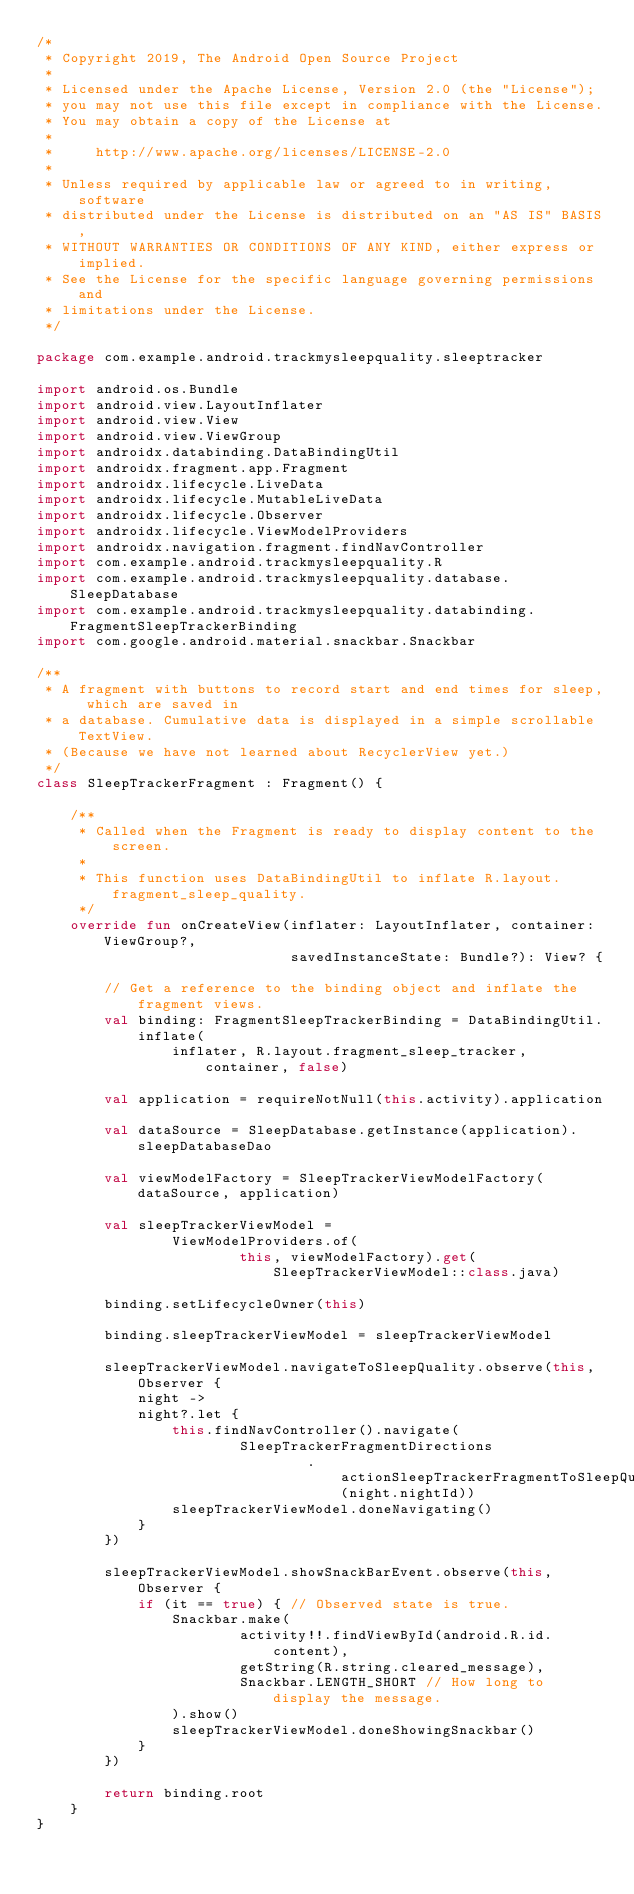Convert code to text. <code><loc_0><loc_0><loc_500><loc_500><_Kotlin_>/*
 * Copyright 2019, The Android Open Source Project
 *
 * Licensed under the Apache License, Version 2.0 (the "License");
 * you may not use this file except in compliance with the License.
 * You may obtain a copy of the License at
 *
 *     http://www.apache.org/licenses/LICENSE-2.0
 *
 * Unless required by applicable law or agreed to in writing, software
 * distributed under the License is distributed on an "AS IS" BASIS,
 * WITHOUT WARRANTIES OR CONDITIONS OF ANY KIND, either express or implied.
 * See the License for the specific language governing permissions and
 * limitations under the License.
 */

package com.example.android.trackmysleepquality.sleeptracker

import android.os.Bundle
import android.view.LayoutInflater
import android.view.View
import android.view.ViewGroup
import androidx.databinding.DataBindingUtil
import androidx.fragment.app.Fragment
import androidx.lifecycle.LiveData
import androidx.lifecycle.MutableLiveData
import androidx.lifecycle.Observer
import androidx.lifecycle.ViewModelProviders
import androidx.navigation.fragment.findNavController
import com.example.android.trackmysleepquality.R
import com.example.android.trackmysleepquality.database.SleepDatabase
import com.example.android.trackmysleepquality.databinding.FragmentSleepTrackerBinding
import com.google.android.material.snackbar.Snackbar

/**
 * A fragment with buttons to record start and end times for sleep, which are saved in
 * a database. Cumulative data is displayed in a simple scrollable TextView.
 * (Because we have not learned about RecyclerView yet.)
 */
class SleepTrackerFragment : Fragment() {

    /**
     * Called when the Fragment is ready to display content to the screen.
     *
     * This function uses DataBindingUtil to inflate R.layout.fragment_sleep_quality.
     */
    override fun onCreateView(inflater: LayoutInflater, container: ViewGroup?,
                              savedInstanceState: Bundle?): View? {

        // Get a reference to the binding object and inflate the fragment views.
        val binding: FragmentSleepTrackerBinding = DataBindingUtil.inflate(
                inflater, R.layout.fragment_sleep_tracker, container, false)

        val application = requireNotNull(this.activity).application

        val dataSource = SleepDatabase.getInstance(application).sleepDatabaseDao

        val viewModelFactory = SleepTrackerViewModelFactory(dataSource, application)

        val sleepTrackerViewModel =
                ViewModelProviders.of(
                        this, viewModelFactory).get(SleepTrackerViewModel::class.java)

        binding.setLifecycleOwner(this)

        binding.sleepTrackerViewModel = sleepTrackerViewModel

        sleepTrackerViewModel.navigateToSleepQuality.observe(this, Observer {
            night ->
            night?.let {
                this.findNavController().navigate(
                        SleepTrackerFragmentDirections
                                .actionSleepTrackerFragmentToSleepQualityFragment(night.nightId))
                sleepTrackerViewModel.doneNavigating()
            }
        })

        sleepTrackerViewModel.showSnackBarEvent.observe(this, Observer {
            if (it == true) { // Observed state is true.
                Snackbar.make(
                        activity!!.findViewById(android.R.id.content),
                        getString(R.string.cleared_message),
                        Snackbar.LENGTH_SHORT // How long to display the message.
                ).show()
                sleepTrackerViewModel.doneShowingSnackbar()
            }
        })

        return binding.root
    }
}
</code> 